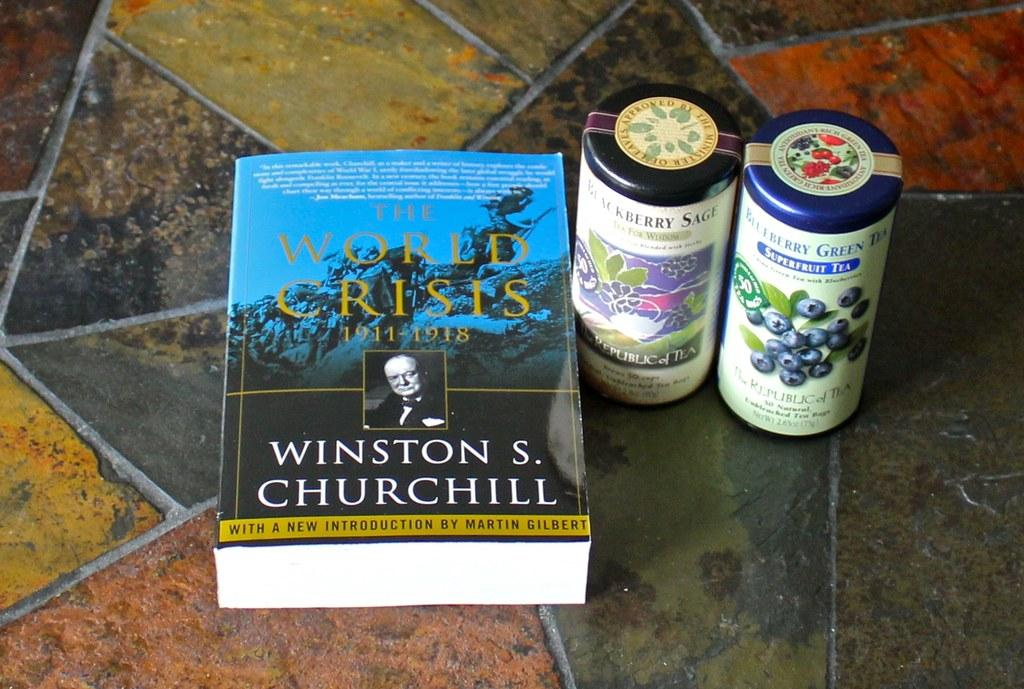<image>
Render a clear and concise summary of the photo. the name Winston is on the book on the ground 